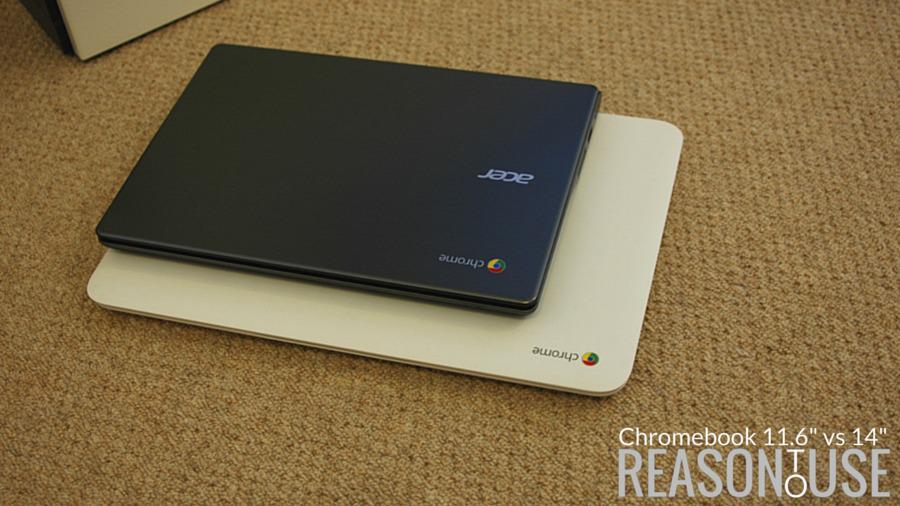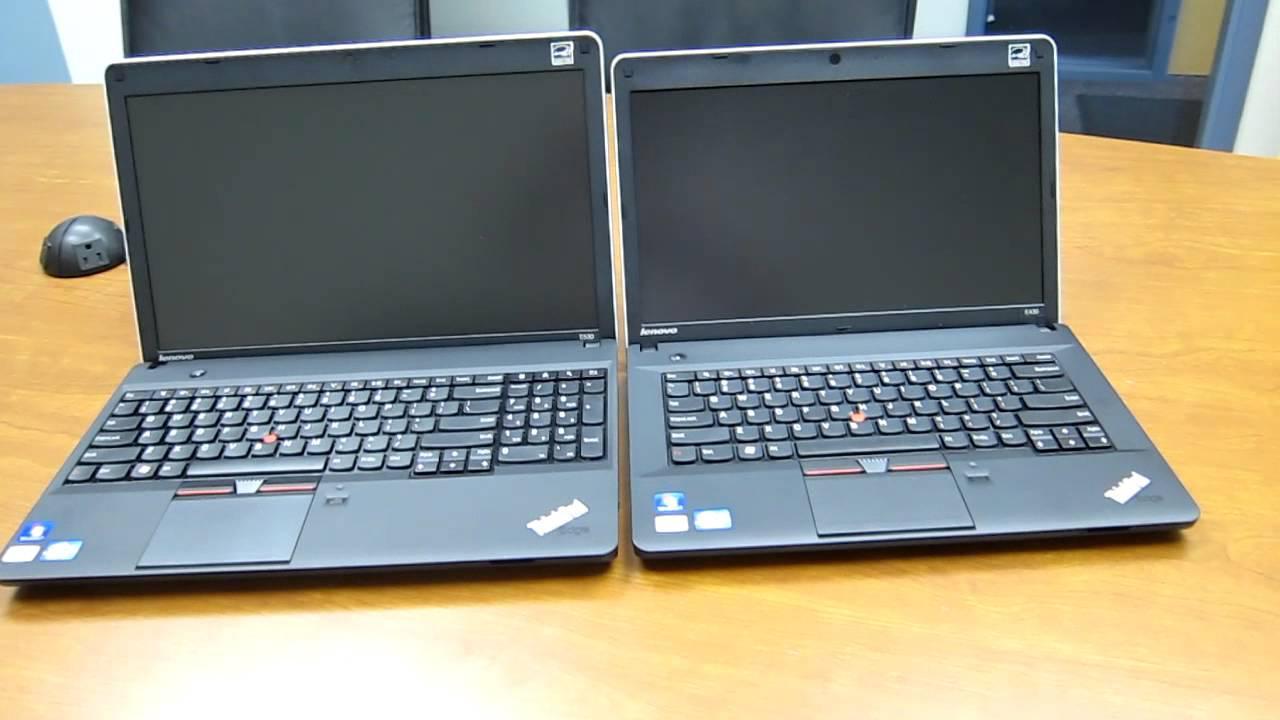The first image is the image on the left, the second image is the image on the right. Given the left and right images, does the statement "One image shows side by side open laptops, and the other shows a small laptop resting on top of a bigger one." hold true? Answer yes or no. Yes. The first image is the image on the left, the second image is the image on the right. Considering the images on both sides, is "Exactly two open laptops can be seen on the image on the right." valid? Answer yes or no. Yes. 